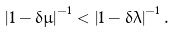<formula> <loc_0><loc_0><loc_500><loc_500>\left | 1 - \delta \mu \right | ^ { - 1 } < \left | 1 - \delta \lambda \right | ^ { - 1 } .</formula> 